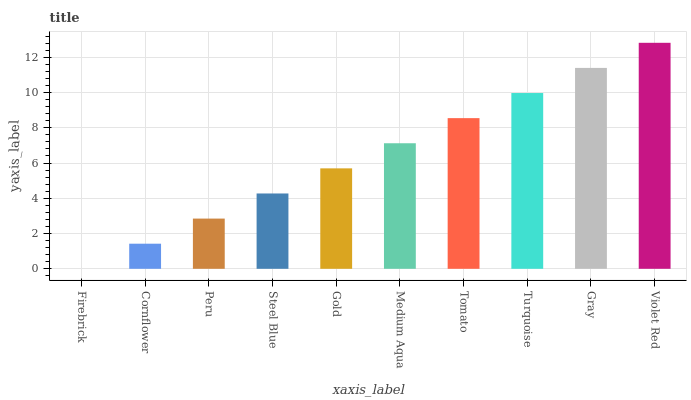Is Firebrick the minimum?
Answer yes or no. Yes. Is Violet Red the maximum?
Answer yes or no. Yes. Is Cornflower the minimum?
Answer yes or no. No. Is Cornflower the maximum?
Answer yes or no. No. Is Cornflower greater than Firebrick?
Answer yes or no. Yes. Is Firebrick less than Cornflower?
Answer yes or no. Yes. Is Firebrick greater than Cornflower?
Answer yes or no. No. Is Cornflower less than Firebrick?
Answer yes or no. No. Is Medium Aqua the high median?
Answer yes or no. Yes. Is Gold the low median?
Answer yes or no. Yes. Is Tomato the high median?
Answer yes or no. No. Is Steel Blue the low median?
Answer yes or no. No. 